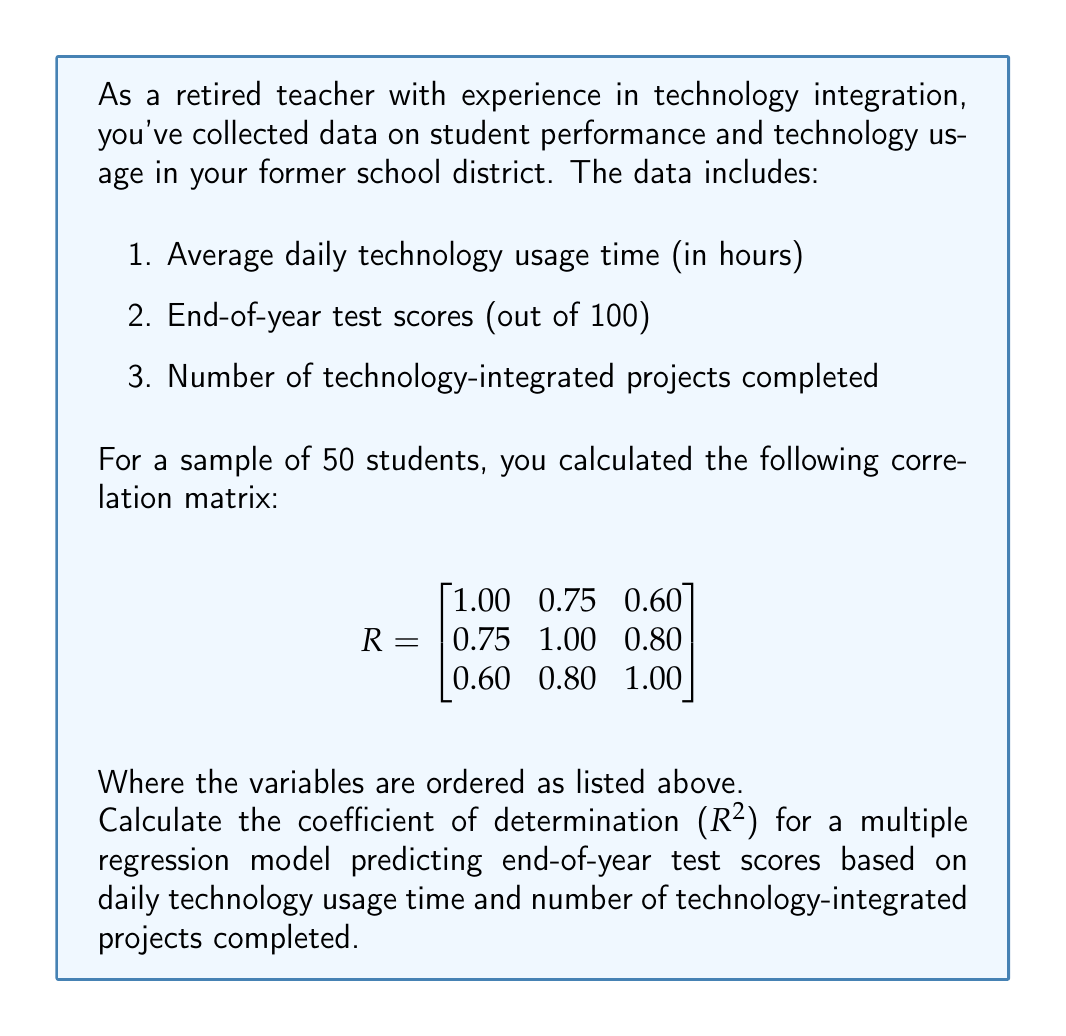Could you help me with this problem? To solve this problem, we'll follow these steps:

1) The coefficient of determination ($R^2$) in multiple regression is equal to the squared multiple correlation coefficient.

2) For a two-predictor model, the formula for the squared multiple correlation coefficient is:

   $$R^2 = \frac{r_{12}^2 + r_{13}^2 - 2r_{12}r_{13}r_{23}}{1 - r_{23}^2}$$

   Where:
   - $r_{12}$ is the correlation between the dependent variable (test scores) and the first predictor (daily technology usage)
   - $r_{13}$ is the correlation between the dependent variable and the second predictor (number of projects)
   - $r_{23}$ is the correlation between the two predictors

3) From the correlation matrix:
   - $r_{12} = 0.75$
   - $r_{13} = 0.80$
   - $r_{23} = 0.60$

4) Let's substitute these values into the formula:

   $$R^2 = \frac{0.75^2 + 0.80^2 - 2(0.75)(0.80)(0.60)}{1 - 0.60^2}$$

5) Calculate the numerator:
   $$0.75^2 + 0.80^2 = 0.5625 + 0.6400 = 1.2025$$
   $$2(0.75)(0.80)(0.60) = 0.72$$
   $$1.2025 - 0.72 = 0.4825$$

6) Calculate the denominator:
   $$1 - 0.60^2 = 1 - 0.36 = 0.64$$

7) Divide:
   $$R^2 = \frac{0.4825}{0.64} = 0.7539$$

Therefore, the coefficient of determination is approximately 0.7539 or 75.39%.
Answer: $R^2 \approx 0.7539$ 